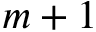Convert formula to latex. <formula><loc_0><loc_0><loc_500><loc_500>m + 1</formula> 